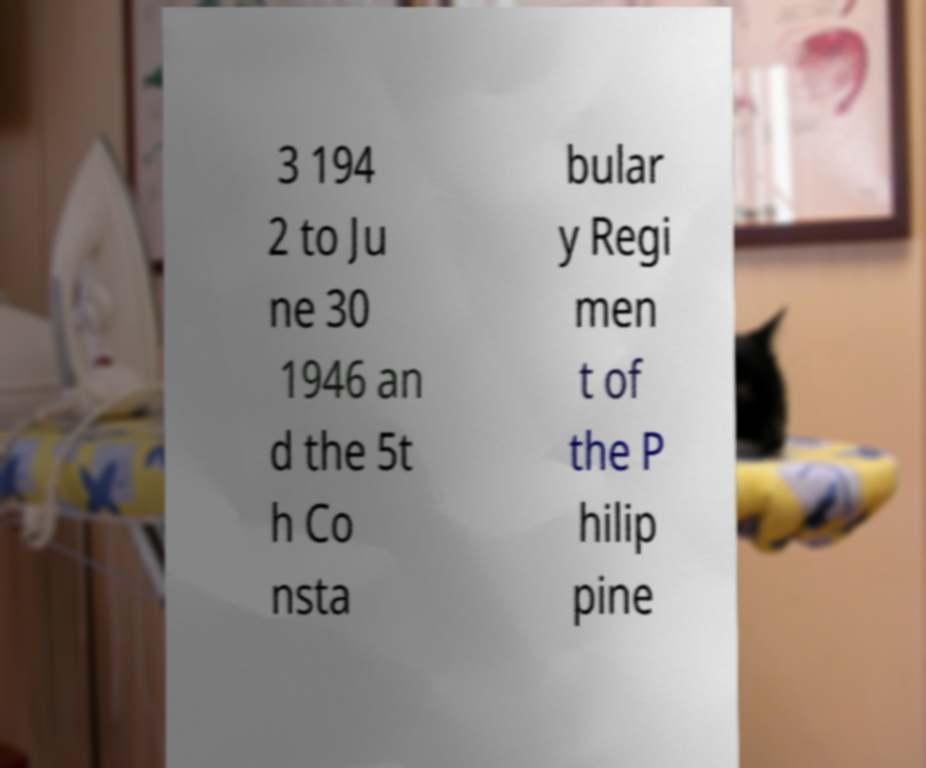What messages or text are displayed in this image? I need them in a readable, typed format. 3 194 2 to Ju ne 30 1946 an d the 5t h Co nsta bular y Regi men t of the P hilip pine 